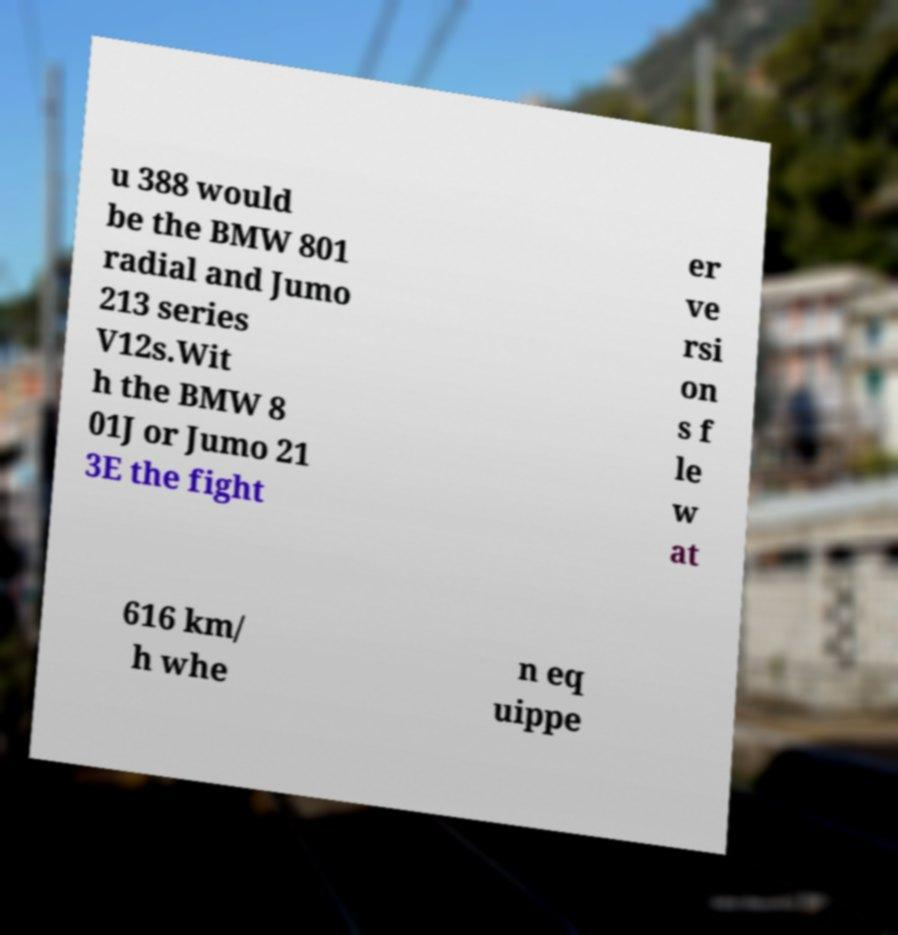Please read and relay the text visible in this image. What does it say? u 388 would be the BMW 801 radial and Jumo 213 series V12s.Wit h the BMW 8 01J or Jumo 21 3E the fight er ve rsi on s f le w at 616 km/ h whe n eq uippe 